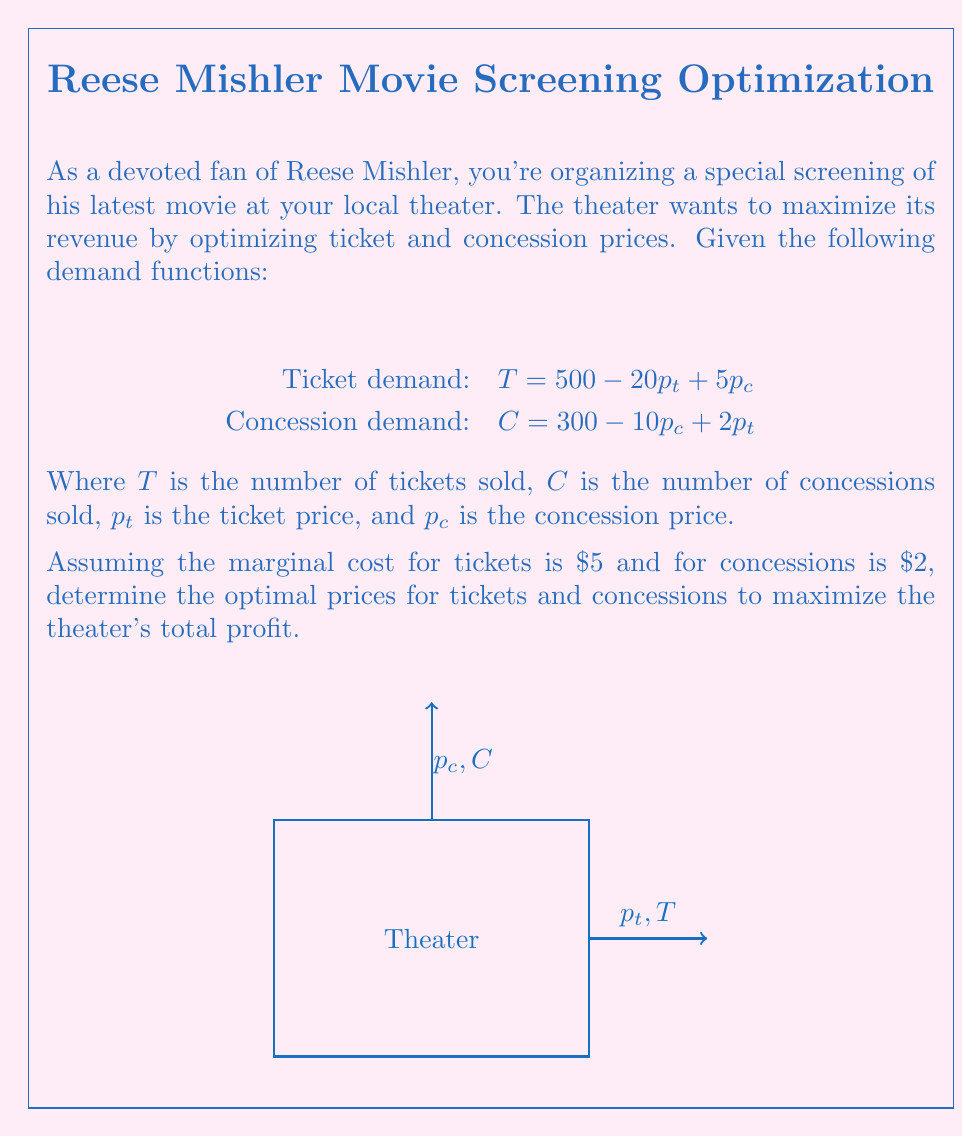Can you answer this question? Let's approach this step-by-step:

1) First, we need to set up the profit function. Profit is revenue minus costs:

   $\Pi = p_t T + p_c C - 5T - 2C$

2) Substitute the demand functions:

   $\Pi = p_t(500 - 20p_t + 5p_c) + p_c(300 - 10p_c + 2p_t) - 5(500 - 20p_t + 5p_c) - 2(300 - 10p_c + 2p_t)$

3) Expand and simplify:

   $\Pi = 500p_t - 20p_t^2 + 5p_tp_c + 300p_c - 10p_c^2 + 2p_tp_c - 2500 + 100p_t - 25p_c - 600 + 20p_c - 4p_t$

   $\Pi = -20p_t^2 - 10p_c^2 + 7p_tp_c + 596p_t + 295p_c - 3100$

4) To find the maximum, we take partial derivatives with respect to $p_t$ and $p_c$ and set them to zero:

   $\frac{\partial \Pi}{\partial p_t} = -40p_t + 7p_c + 596 = 0$
   $\frac{\partial \Pi}{\partial p_c} = -20p_c + 7p_t + 295 = 0$

5) Solve this system of equations:
   From the second equation: $p_t = \frac{20p_c - 295}{7}$
   
   Substitute into the first equation:
   
   $-40(\frac{20p_c - 295}{7}) + 7p_c + 596 = 0$
   
   $-800p_c + 11800 + 49p_c + 4172 = 0$
   $-751p_c + 15972 = 0$
   $p_c = 21.27$

6) Substitute back to find $p_t$:

   $p_t = \frac{20(21.27) - 295}{7} = 32.20$

7) Round to the nearest cent for practical pricing:

   $p_t = $32.20
   $p_c = $21.27
Answer: Optimal ticket price: $32.20, Optimal concession price: $21.27 